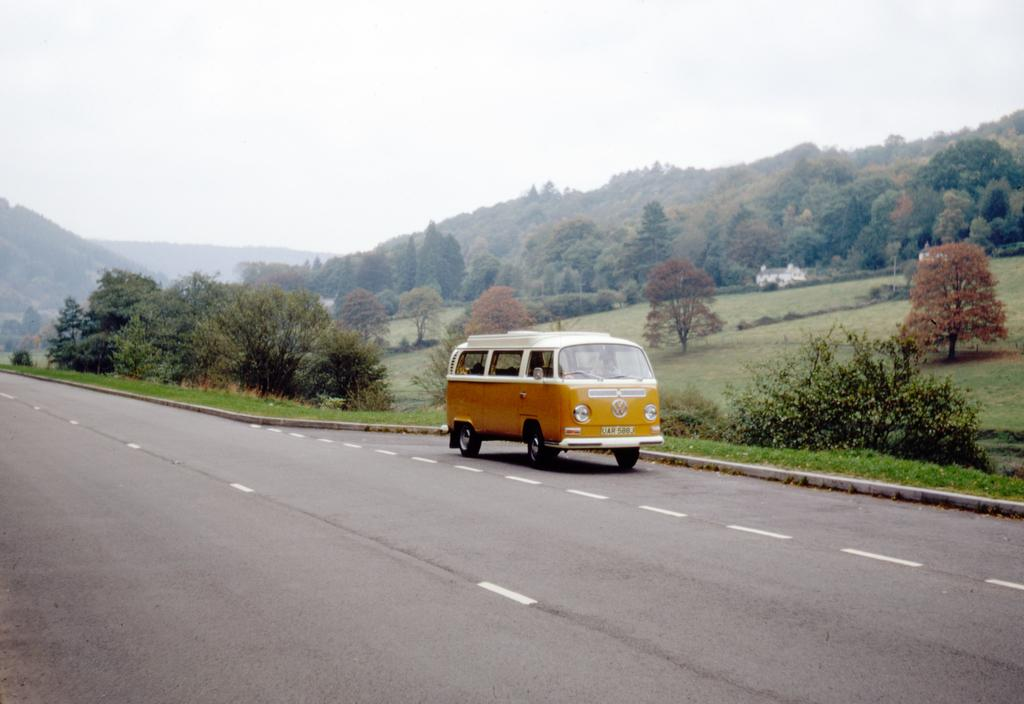What is on the road in the image? There is a vehicle on the road in the image. What can be seen in the background of the image? There are trees, plants, grass, hills, and the sky visible in the background of the image. What might indicate the presence of a road in the image? The presence of white lines on the road in the image suggests it is a road. How many chairs are visible in the image? There are no chairs present in the image. What type of trail can be seen in the image? There is no trail visible in the image; it features a vehicle on a road with a background of trees, plants, grass, hills, and the sky. 